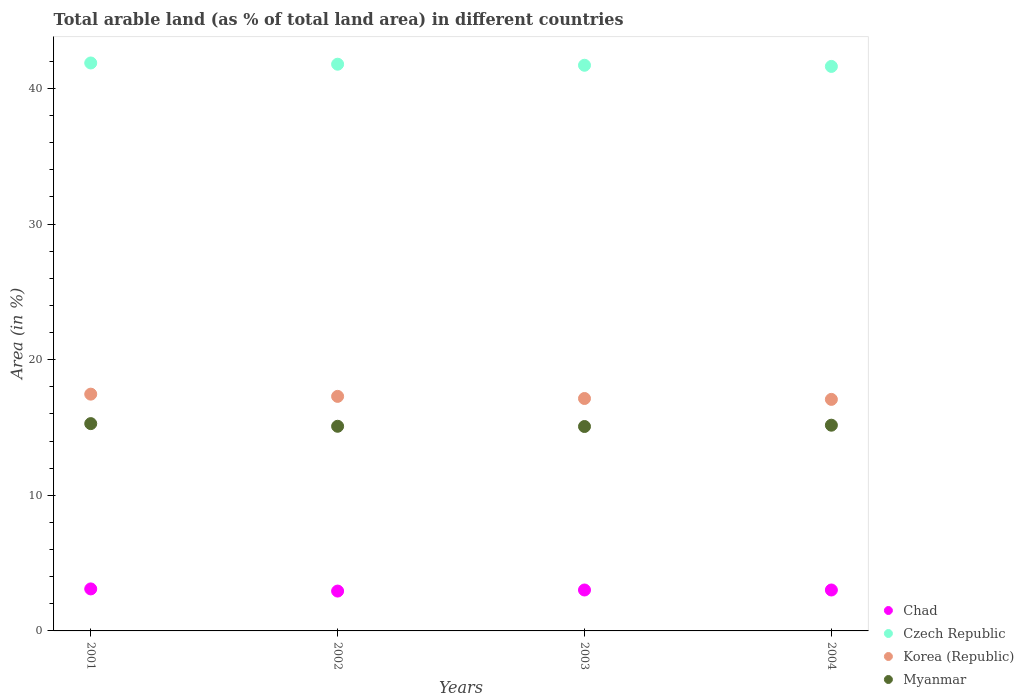Is the number of dotlines equal to the number of legend labels?
Provide a short and direct response. Yes. What is the percentage of arable land in Myanmar in 2002?
Keep it short and to the point. 15.09. Across all years, what is the maximum percentage of arable land in Korea (Republic)?
Your answer should be compact. 17.46. Across all years, what is the minimum percentage of arable land in Korea (Republic)?
Make the answer very short. 17.07. In which year was the percentage of arable land in Myanmar maximum?
Make the answer very short. 2001. What is the total percentage of arable land in Korea (Republic) in the graph?
Provide a short and direct response. 68.97. What is the difference between the percentage of arable land in Czech Republic in 2003 and that in 2004?
Your response must be concise. 0.09. What is the difference between the percentage of arable land in Chad in 2004 and the percentage of arable land in Czech Republic in 2002?
Your answer should be compact. -38.77. What is the average percentage of arable land in Korea (Republic) per year?
Your response must be concise. 17.24. In the year 2002, what is the difference between the percentage of arable land in Chad and percentage of arable land in Czech Republic?
Offer a terse response. -38.85. In how many years, is the percentage of arable land in Chad greater than 16 %?
Offer a terse response. 0. What is the ratio of the percentage of arable land in Chad in 2001 to that in 2002?
Provide a succinct answer. 1.05. Is the percentage of arable land in Myanmar in 2002 less than that in 2003?
Your response must be concise. No. What is the difference between the highest and the second highest percentage of arable land in Myanmar?
Your answer should be very brief. 0.12. What is the difference between the highest and the lowest percentage of arable land in Czech Republic?
Your answer should be very brief. 0.25. Is it the case that in every year, the sum of the percentage of arable land in Chad and percentage of arable land in Korea (Republic)  is greater than the sum of percentage of arable land in Czech Republic and percentage of arable land in Myanmar?
Ensure brevity in your answer.  No. Does the percentage of arable land in Myanmar monotonically increase over the years?
Your answer should be very brief. No. Is the percentage of arable land in Korea (Republic) strictly greater than the percentage of arable land in Myanmar over the years?
Provide a short and direct response. Yes. What is the difference between two consecutive major ticks on the Y-axis?
Keep it short and to the point. 10. Are the values on the major ticks of Y-axis written in scientific E-notation?
Your answer should be compact. No. Does the graph contain any zero values?
Make the answer very short. No. Does the graph contain grids?
Give a very brief answer. No. How many legend labels are there?
Provide a short and direct response. 4. How are the legend labels stacked?
Your response must be concise. Vertical. What is the title of the graph?
Provide a succinct answer. Total arable land (as % of total land area) in different countries. What is the label or title of the Y-axis?
Offer a terse response. Area (in %). What is the Area (in %) in Chad in 2001?
Make the answer very short. 3.1. What is the Area (in %) of Czech Republic in 2001?
Your answer should be very brief. 41.88. What is the Area (in %) in Korea (Republic) in 2001?
Ensure brevity in your answer.  17.46. What is the Area (in %) of Myanmar in 2001?
Provide a short and direct response. 15.29. What is the Area (in %) in Chad in 2002?
Keep it short and to the point. 2.94. What is the Area (in %) in Czech Republic in 2002?
Offer a very short reply. 41.79. What is the Area (in %) of Korea (Republic) in 2002?
Your answer should be very brief. 17.3. What is the Area (in %) in Myanmar in 2002?
Your answer should be compact. 15.09. What is the Area (in %) in Chad in 2003?
Ensure brevity in your answer.  3.02. What is the Area (in %) in Czech Republic in 2003?
Keep it short and to the point. 41.71. What is the Area (in %) in Korea (Republic) in 2003?
Offer a terse response. 17.14. What is the Area (in %) of Myanmar in 2003?
Offer a very short reply. 15.07. What is the Area (in %) of Chad in 2004?
Ensure brevity in your answer.  3.02. What is the Area (in %) of Czech Republic in 2004?
Your response must be concise. 41.63. What is the Area (in %) in Korea (Republic) in 2004?
Provide a succinct answer. 17.07. What is the Area (in %) in Myanmar in 2004?
Give a very brief answer. 15.17. Across all years, what is the maximum Area (in %) of Chad?
Provide a succinct answer. 3.1. Across all years, what is the maximum Area (in %) in Czech Republic?
Your answer should be very brief. 41.88. Across all years, what is the maximum Area (in %) of Korea (Republic)?
Ensure brevity in your answer.  17.46. Across all years, what is the maximum Area (in %) of Myanmar?
Ensure brevity in your answer.  15.29. Across all years, what is the minimum Area (in %) in Chad?
Provide a succinct answer. 2.94. Across all years, what is the minimum Area (in %) of Czech Republic?
Offer a terse response. 41.63. Across all years, what is the minimum Area (in %) in Korea (Republic)?
Your response must be concise. 17.07. Across all years, what is the minimum Area (in %) in Myanmar?
Offer a terse response. 15.07. What is the total Area (in %) in Chad in the graph?
Provide a short and direct response. 12.07. What is the total Area (in %) of Czech Republic in the graph?
Give a very brief answer. 167. What is the total Area (in %) of Korea (Republic) in the graph?
Keep it short and to the point. 68.97. What is the total Area (in %) of Myanmar in the graph?
Give a very brief answer. 60.62. What is the difference between the Area (in %) in Chad in 2001 and that in 2002?
Your answer should be compact. 0.16. What is the difference between the Area (in %) of Czech Republic in 2001 and that in 2002?
Offer a very short reply. 0.09. What is the difference between the Area (in %) of Korea (Republic) in 2001 and that in 2002?
Your answer should be compact. 0.16. What is the difference between the Area (in %) of Myanmar in 2001 and that in 2002?
Offer a very short reply. 0.2. What is the difference between the Area (in %) of Chad in 2001 and that in 2003?
Give a very brief answer. 0.08. What is the difference between the Area (in %) of Czech Republic in 2001 and that in 2003?
Your answer should be very brief. 0.17. What is the difference between the Area (in %) of Korea (Republic) in 2001 and that in 2003?
Make the answer very short. 0.32. What is the difference between the Area (in %) in Myanmar in 2001 and that in 2003?
Provide a short and direct response. 0.21. What is the difference between the Area (in %) in Chad in 2001 and that in 2004?
Make the answer very short. 0.08. What is the difference between the Area (in %) of Czech Republic in 2001 and that in 2004?
Your response must be concise. 0.25. What is the difference between the Area (in %) of Korea (Republic) in 2001 and that in 2004?
Offer a terse response. 0.39. What is the difference between the Area (in %) of Myanmar in 2001 and that in 2004?
Offer a very short reply. 0.12. What is the difference between the Area (in %) in Chad in 2002 and that in 2003?
Keep it short and to the point. -0.08. What is the difference between the Area (in %) in Czech Republic in 2002 and that in 2003?
Offer a very short reply. 0.08. What is the difference between the Area (in %) of Korea (Republic) in 2002 and that in 2003?
Offer a terse response. 0.16. What is the difference between the Area (in %) of Myanmar in 2002 and that in 2003?
Give a very brief answer. 0.02. What is the difference between the Area (in %) of Chad in 2002 and that in 2004?
Provide a short and direct response. -0.08. What is the difference between the Area (in %) of Czech Republic in 2002 and that in 2004?
Keep it short and to the point. 0.16. What is the difference between the Area (in %) in Korea (Republic) in 2002 and that in 2004?
Provide a short and direct response. 0.22. What is the difference between the Area (in %) of Myanmar in 2002 and that in 2004?
Provide a short and direct response. -0.08. What is the difference between the Area (in %) of Czech Republic in 2003 and that in 2004?
Provide a short and direct response. 0.09. What is the difference between the Area (in %) of Korea (Republic) in 2003 and that in 2004?
Offer a very short reply. 0.07. What is the difference between the Area (in %) in Myanmar in 2003 and that in 2004?
Your response must be concise. -0.1. What is the difference between the Area (in %) of Chad in 2001 and the Area (in %) of Czech Republic in 2002?
Offer a terse response. -38.69. What is the difference between the Area (in %) of Chad in 2001 and the Area (in %) of Korea (Republic) in 2002?
Your answer should be compact. -14.2. What is the difference between the Area (in %) in Chad in 2001 and the Area (in %) in Myanmar in 2002?
Offer a terse response. -11.99. What is the difference between the Area (in %) in Czech Republic in 2001 and the Area (in %) in Korea (Republic) in 2002?
Your response must be concise. 24.58. What is the difference between the Area (in %) of Czech Republic in 2001 and the Area (in %) of Myanmar in 2002?
Provide a short and direct response. 26.79. What is the difference between the Area (in %) in Korea (Republic) in 2001 and the Area (in %) in Myanmar in 2002?
Provide a short and direct response. 2.37. What is the difference between the Area (in %) in Chad in 2001 and the Area (in %) in Czech Republic in 2003?
Offer a terse response. -38.61. What is the difference between the Area (in %) in Chad in 2001 and the Area (in %) in Korea (Republic) in 2003?
Offer a terse response. -14.04. What is the difference between the Area (in %) of Chad in 2001 and the Area (in %) of Myanmar in 2003?
Your answer should be very brief. -11.98. What is the difference between the Area (in %) in Czech Republic in 2001 and the Area (in %) in Korea (Republic) in 2003?
Your response must be concise. 24.74. What is the difference between the Area (in %) in Czech Republic in 2001 and the Area (in %) in Myanmar in 2003?
Make the answer very short. 26.81. What is the difference between the Area (in %) in Korea (Republic) in 2001 and the Area (in %) in Myanmar in 2003?
Provide a succinct answer. 2.39. What is the difference between the Area (in %) of Chad in 2001 and the Area (in %) of Czech Republic in 2004?
Offer a very short reply. -38.53. What is the difference between the Area (in %) of Chad in 2001 and the Area (in %) of Korea (Republic) in 2004?
Ensure brevity in your answer.  -13.98. What is the difference between the Area (in %) of Chad in 2001 and the Area (in %) of Myanmar in 2004?
Offer a terse response. -12.07. What is the difference between the Area (in %) of Czech Republic in 2001 and the Area (in %) of Korea (Republic) in 2004?
Make the answer very short. 24.81. What is the difference between the Area (in %) of Czech Republic in 2001 and the Area (in %) of Myanmar in 2004?
Give a very brief answer. 26.71. What is the difference between the Area (in %) of Korea (Republic) in 2001 and the Area (in %) of Myanmar in 2004?
Your answer should be very brief. 2.29. What is the difference between the Area (in %) of Chad in 2002 and the Area (in %) of Czech Republic in 2003?
Make the answer very short. -38.77. What is the difference between the Area (in %) in Chad in 2002 and the Area (in %) in Korea (Republic) in 2003?
Your answer should be compact. -14.2. What is the difference between the Area (in %) in Chad in 2002 and the Area (in %) in Myanmar in 2003?
Offer a very short reply. -12.13. What is the difference between the Area (in %) in Czech Republic in 2002 and the Area (in %) in Korea (Republic) in 2003?
Your answer should be compact. 24.65. What is the difference between the Area (in %) of Czech Republic in 2002 and the Area (in %) of Myanmar in 2003?
Your answer should be compact. 26.72. What is the difference between the Area (in %) in Korea (Republic) in 2002 and the Area (in %) in Myanmar in 2003?
Offer a terse response. 2.22. What is the difference between the Area (in %) in Chad in 2002 and the Area (in %) in Czech Republic in 2004?
Offer a very short reply. -38.69. What is the difference between the Area (in %) in Chad in 2002 and the Area (in %) in Korea (Republic) in 2004?
Your answer should be compact. -14.13. What is the difference between the Area (in %) in Chad in 2002 and the Area (in %) in Myanmar in 2004?
Your answer should be very brief. -12.23. What is the difference between the Area (in %) of Czech Republic in 2002 and the Area (in %) of Korea (Republic) in 2004?
Your answer should be compact. 24.72. What is the difference between the Area (in %) in Czech Republic in 2002 and the Area (in %) in Myanmar in 2004?
Your answer should be compact. 26.62. What is the difference between the Area (in %) of Korea (Republic) in 2002 and the Area (in %) of Myanmar in 2004?
Ensure brevity in your answer.  2.13. What is the difference between the Area (in %) of Chad in 2003 and the Area (in %) of Czech Republic in 2004?
Ensure brevity in your answer.  -38.61. What is the difference between the Area (in %) in Chad in 2003 and the Area (in %) in Korea (Republic) in 2004?
Keep it short and to the point. -14.06. What is the difference between the Area (in %) of Chad in 2003 and the Area (in %) of Myanmar in 2004?
Offer a very short reply. -12.15. What is the difference between the Area (in %) in Czech Republic in 2003 and the Area (in %) in Korea (Republic) in 2004?
Keep it short and to the point. 24.64. What is the difference between the Area (in %) in Czech Republic in 2003 and the Area (in %) in Myanmar in 2004?
Keep it short and to the point. 26.54. What is the difference between the Area (in %) in Korea (Republic) in 2003 and the Area (in %) in Myanmar in 2004?
Make the answer very short. 1.97. What is the average Area (in %) of Chad per year?
Your answer should be compact. 3.02. What is the average Area (in %) in Czech Republic per year?
Offer a very short reply. 41.75. What is the average Area (in %) of Korea (Republic) per year?
Provide a short and direct response. 17.24. What is the average Area (in %) in Myanmar per year?
Your response must be concise. 15.15. In the year 2001, what is the difference between the Area (in %) of Chad and Area (in %) of Czech Republic?
Offer a very short reply. -38.78. In the year 2001, what is the difference between the Area (in %) in Chad and Area (in %) in Korea (Republic)?
Provide a succinct answer. -14.36. In the year 2001, what is the difference between the Area (in %) in Chad and Area (in %) in Myanmar?
Provide a succinct answer. -12.19. In the year 2001, what is the difference between the Area (in %) in Czech Republic and Area (in %) in Korea (Republic)?
Your answer should be very brief. 24.42. In the year 2001, what is the difference between the Area (in %) of Czech Republic and Area (in %) of Myanmar?
Your response must be concise. 26.59. In the year 2001, what is the difference between the Area (in %) in Korea (Republic) and Area (in %) in Myanmar?
Give a very brief answer. 2.17. In the year 2002, what is the difference between the Area (in %) in Chad and Area (in %) in Czech Republic?
Keep it short and to the point. -38.85. In the year 2002, what is the difference between the Area (in %) in Chad and Area (in %) in Korea (Republic)?
Offer a terse response. -14.36. In the year 2002, what is the difference between the Area (in %) in Chad and Area (in %) in Myanmar?
Give a very brief answer. -12.15. In the year 2002, what is the difference between the Area (in %) of Czech Republic and Area (in %) of Korea (Republic)?
Offer a terse response. 24.49. In the year 2002, what is the difference between the Area (in %) in Czech Republic and Area (in %) in Myanmar?
Your answer should be very brief. 26.7. In the year 2002, what is the difference between the Area (in %) of Korea (Republic) and Area (in %) of Myanmar?
Your answer should be compact. 2.21. In the year 2003, what is the difference between the Area (in %) of Chad and Area (in %) of Czech Republic?
Offer a terse response. -38.69. In the year 2003, what is the difference between the Area (in %) in Chad and Area (in %) in Korea (Republic)?
Ensure brevity in your answer.  -14.12. In the year 2003, what is the difference between the Area (in %) of Chad and Area (in %) of Myanmar?
Your answer should be compact. -12.06. In the year 2003, what is the difference between the Area (in %) in Czech Republic and Area (in %) in Korea (Republic)?
Provide a succinct answer. 24.57. In the year 2003, what is the difference between the Area (in %) in Czech Republic and Area (in %) in Myanmar?
Provide a succinct answer. 26.64. In the year 2003, what is the difference between the Area (in %) in Korea (Republic) and Area (in %) in Myanmar?
Provide a short and direct response. 2.07. In the year 2004, what is the difference between the Area (in %) in Chad and Area (in %) in Czech Republic?
Provide a succinct answer. -38.61. In the year 2004, what is the difference between the Area (in %) of Chad and Area (in %) of Korea (Republic)?
Offer a very short reply. -14.06. In the year 2004, what is the difference between the Area (in %) of Chad and Area (in %) of Myanmar?
Your answer should be very brief. -12.15. In the year 2004, what is the difference between the Area (in %) of Czech Republic and Area (in %) of Korea (Republic)?
Provide a short and direct response. 24.55. In the year 2004, what is the difference between the Area (in %) of Czech Republic and Area (in %) of Myanmar?
Offer a very short reply. 26.46. In the year 2004, what is the difference between the Area (in %) of Korea (Republic) and Area (in %) of Myanmar?
Provide a succinct answer. 1.9. What is the ratio of the Area (in %) in Chad in 2001 to that in 2002?
Provide a short and direct response. 1.05. What is the ratio of the Area (in %) in Czech Republic in 2001 to that in 2002?
Your answer should be compact. 1. What is the ratio of the Area (in %) in Korea (Republic) in 2001 to that in 2002?
Your answer should be very brief. 1.01. What is the ratio of the Area (in %) in Chad in 2001 to that in 2003?
Make the answer very short. 1.03. What is the ratio of the Area (in %) in Korea (Republic) in 2001 to that in 2003?
Keep it short and to the point. 1.02. What is the ratio of the Area (in %) of Myanmar in 2001 to that in 2003?
Make the answer very short. 1.01. What is the ratio of the Area (in %) of Chad in 2001 to that in 2004?
Ensure brevity in your answer.  1.03. What is the ratio of the Area (in %) in Czech Republic in 2001 to that in 2004?
Provide a succinct answer. 1.01. What is the ratio of the Area (in %) in Korea (Republic) in 2001 to that in 2004?
Make the answer very short. 1.02. What is the ratio of the Area (in %) of Myanmar in 2001 to that in 2004?
Provide a succinct answer. 1.01. What is the ratio of the Area (in %) in Chad in 2002 to that in 2003?
Provide a short and direct response. 0.97. What is the ratio of the Area (in %) of Korea (Republic) in 2002 to that in 2003?
Your answer should be very brief. 1.01. What is the ratio of the Area (in %) in Chad in 2002 to that in 2004?
Your answer should be compact. 0.97. What is the ratio of the Area (in %) in Czech Republic in 2002 to that in 2004?
Your response must be concise. 1. What is the ratio of the Area (in %) in Chad in 2003 to that in 2004?
Provide a succinct answer. 1. What is the ratio of the Area (in %) in Czech Republic in 2003 to that in 2004?
Ensure brevity in your answer.  1. What is the ratio of the Area (in %) of Korea (Republic) in 2003 to that in 2004?
Ensure brevity in your answer.  1. What is the difference between the highest and the second highest Area (in %) in Chad?
Provide a short and direct response. 0.08. What is the difference between the highest and the second highest Area (in %) of Czech Republic?
Keep it short and to the point. 0.09. What is the difference between the highest and the second highest Area (in %) in Korea (Republic)?
Your answer should be very brief. 0.16. What is the difference between the highest and the second highest Area (in %) of Myanmar?
Offer a very short reply. 0.12. What is the difference between the highest and the lowest Area (in %) in Chad?
Your response must be concise. 0.16. What is the difference between the highest and the lowest Area (in %) of Czech Republic?
Ensure brevity in your answer.  0.25. What is the difference between the highest and the lowest Area (in %) of Korea (Republic)?
Ensure brevity in your answer.  0.39. What is the difference between the highest and the lowest Area (in %) in Myanmar?
Provide a succinct answer. 0.21. 